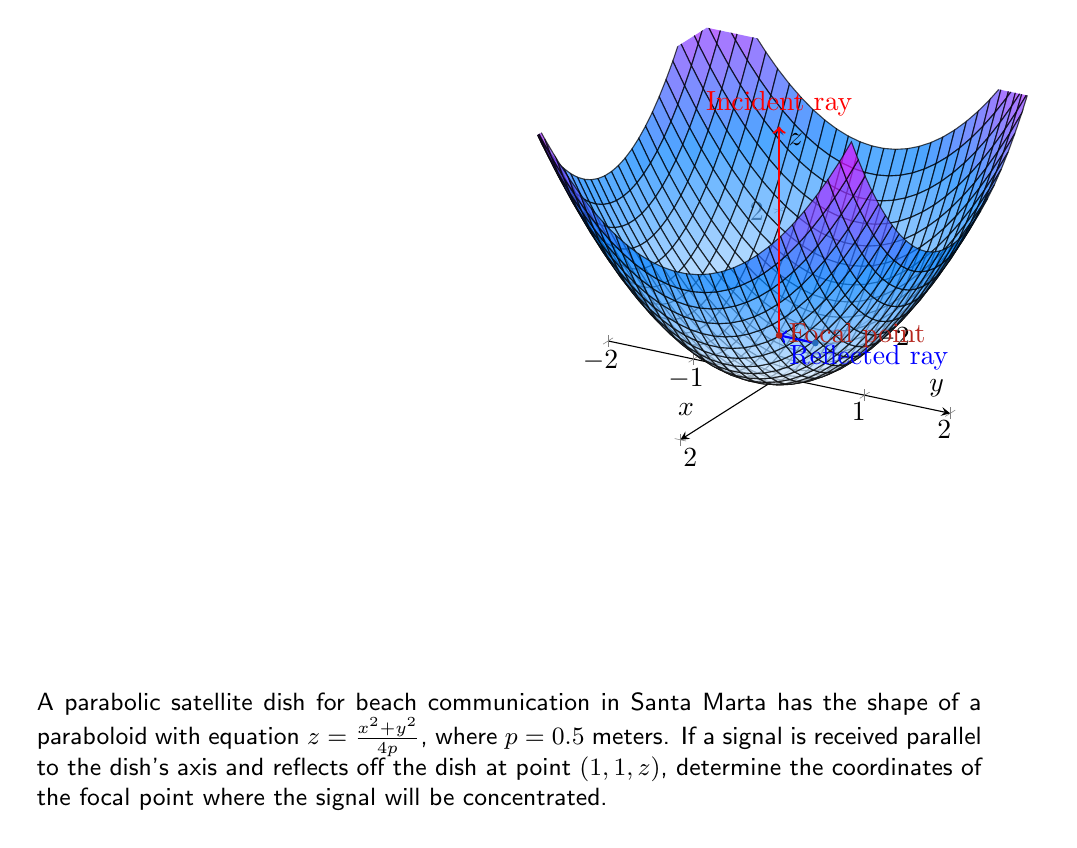Teach me how to tackle this problem. Let's approach this step-by-step:

1) The general equation of a paraboloid is $z = \frac{x^2 + y^2}{4p}$, where $p$ is the focal length. We're given that $p = 0.5$ meters.

2) We know that for a parabolic dish, all signals parallel to the axis will reflect and pass through the focal point. The focal point is located on the z-axis at a distance $p$ from the vertex of the paraboloid.

3) Given that $p = 0.5$, the focal point will be at coordinates $(0, 0, 0.5)$.

4) To verify this, we can use the reflection property of parabolas. The normal line at any point on the parabola bisects the angle between:
   a) The line from that point to the focus
   b) The line parallel to the axis of the parabola

5) Let's consider the given point $(1, 1, z)$. We need to find $z$:

   $z = \frac{x^2 + y^2}{4p} = \frac{1^2 + 1^2}{4(0.5)} = \frac{2}{2} = 1$

   So the point is $(1, 1, 1)$.

6) The vector from this point to the focal point is:
   $\vec{v} = (0-1, 0-1, 0.5-1) = (-1, -1, -0.5)$

7) The vector parallel to the axis (the incident ray) is:
   $\vec{u} = (0, 0, 1)$

8) If our focal point is correct, these vectors should form equal angles with the normal to the surface at $(1, 1, 1)$.

9) The normal vector to the surface is parallel to the gradient:
   $\vec{n} = (\frac{\partial z}{\partial x}, \frac{\partial z}{\partial y}, -1) = (\frac{x}{p}, \frac{y}{p}, -1) = (2, 2, -1)$

10) We can verify that $\vec{v}$ and $\vec{u}$ form equal angles with $\vec{n}$ by comparing their dot products:

    $\vec{v} \cdot \vec{n} = (-1)(2) + (-1)(2) + (-0.5)(-1) = -3.5$
    $\vec{u} \cdot \vec{n} = (0)(2) + (0)(2) + (1)(-1) = -1$

    The cosines of the angles are proportional, confirming that the angles are equal.

Therefore, our calculation of the focal point at $(0, 0, 0.5)$ is correct.
Answer: $(0, 0, 0.5)$ 